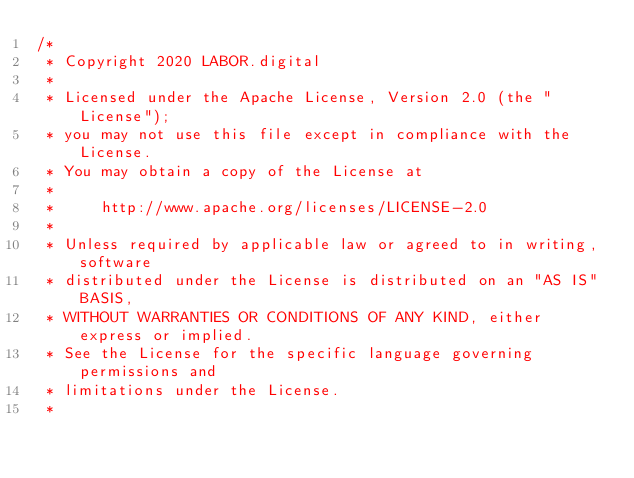<code> <loc_0><loc_0><loc_500><loc_500><_TypeScript_>/*
 * Copyright 2020 LABOR.digital
 *
 * Licensed under the Apache License, Version 2.0 (the "License");
 * you may not use this file except in compliance with the License.
 * You may obtain a copy of the License at
 *
 *     http://www.apache.org/licenses/LICENSE-2.0
 *
 * Unless required by applicable law or agreed to in writing, software
 * distributed under the License is distributed on an "AS IS" BASIS,
 * WITHOUT WARRANTIES OR CONDITIONS OF ANY KIND, either express or implied.
 * See the License for the specific language governing permissions and
 * limitations under the License.
 *</code> 